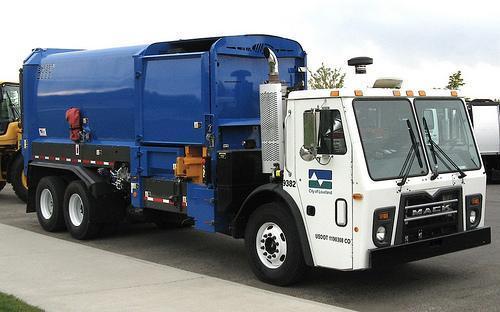How many trucks are visible in the picture?
Give a very brief answer. 1. 